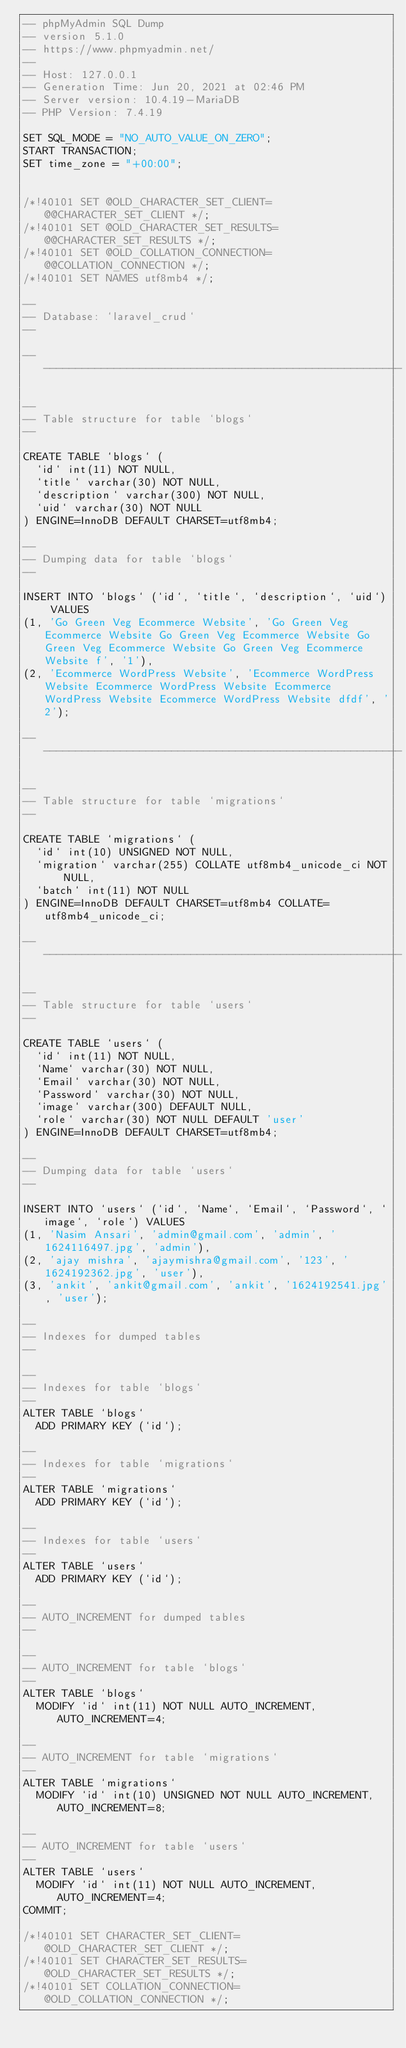<code> <loc_0><loc_0><loc_500><loc_500><_SQL_>-- phpMyAdmin SQL Dump
-- version 5.1.0
-- https://www.phpmyadmin.net/
--
-- Host: 127.0.0.1
-- Generation Time: Jun 20, 2021 at 02:46 PM
-- Server version: 10.4.19-MariaDB
-- PHP Version: 7.4.19

SET SQL_MODE = "NO_AUTO_VALUE_ON_ZERO";
START TRANSACTION;
SET time_zone = "+00:00";


/*!40101 SET @OLD_CHARACTER_SET_CLIENT=@@CHARACTER_SET_CLIENT */;
/*!40101 SET @OLD_CHARACTER_SET_RESULTS=@@CHARACTER_SET_RESULTS */;
/*!40101 SET @OLD_COLLATION_CONNECTION=@@COLLATION_CONNECTION */;
/*!40101 SET NAMES utf8mb4 */;

--
-- Database: `laravel_crud`
--

-- --------------------------------------------------------

--
-- Table structure for table `blogs`
--

CREATE TABLE `blogs` (
  `id` int(11) NOT NULL,
  `title` varchar(30) NOT NULL,
  `description` varchar(300) NOT NULL,
  `uid` varchar(30) NOT NULL
) ENGINE=InnoDB DEFAULT CHARSET=utf8mb4;

--
-- Dumping data for table `blogs`
--

INSERT INTO `blogs` (`id`, `title`, `description`, `uid`) VALUES
(1, 'Go Green Veg Ecommerce Website', 'Go Green Veg Ecommerce Website Go Green Veg Ecommerce Website Go Green Veg Ecommerce Website Go Green Veg Ecommerce Website f', '1'),
(2, 'Ecommerce WordPress Website', 'Ecommerce WordPress Website Ecommerce WordPress Website Ecommerce WordPress Website Ecommerce WordPress Website dfdf', '2');

-- --------------------------------------------------------

--
-- Table structure for table `migrations`
--

CREATE TABLE `migrations` (
  `id` int(10) UNSIGNED NOT NULL,
  `migration` varchar(255) COLLATE utf8mb4_unicode_ci NOT NULL,
  `batch` int(11) NOT NULL
) ENGINE=InnoDB DEFAULT CHARSET=utf8mb4 COLLATE=utf8mb4_unicode_ci;

-- --------------------------------------------------------

--
-- Table structure for table `users`
--

CREATE TABLE `users` (
  `id` int(11) NOT NULL,
  `Name` varchar(30) NOT NULL,
  `Email` varchar(30) NOT NULL,
  `Password` varchar(30) NOT NULL,
  `image` varchar(300) DEFAULT NULL,
  `role` varchar(30) NOT NULL DEFAULT 'user'
) ENGINE=InnoDB DEFAULT CHARSET=utf8mb4;

--
-- Dumping data for table `users`
--

INSERT INTO `users` (`id`, `Name`, `Email`, `Password`, `image`, `role`) VALUES
(1, 'Nasim Ansari', 'admin@gmail.com', 'admin', '1624116497.jpg', 'admin'),
(2, 'ajay mishra', 'ajaymishra@gmail.com', '123', '1624192362.jpg', 'user'),
(3, 'ankit', 'ankit@gmail.com', 'ankit', '1624192541.jpg', 'user');

--
-- Indexes for dumped tables
--

--
-- Indexes for table `blogs`
--
ALTER TABLE `blogs`
  ADD PRIMARY KEY (`id`);

--
-- Indexes for table `migrations`
--
ALTER TABLE `migrations`
  ADD PRIMARY KEY (`id`);

--
-- Indexes for table `users`
--
ALTER TABLE `users`
  ADD PRIMARY KEY (`id`);

--
-- AUTO_INCREMENT for dumped tables
--

--
-- AUTO_INCREMENT for table `blogs`
--
ALTER TABLE `blogs`
  MODIFY `id` int(11) NOT NULL AUTO_INCREMENT, AUTO_INCREMENT=4;

--
-- AUTO_INCREMENT for table `migrations`
--
ALTER TABLE `migrations`
  MODIFY `id` int(10) UNSIGNED NOT NULL AUTO_INCREMENT, AUTO_INCREMENT=8;

--
-- AUTO_INCREMENT for table `users`
--
ALTER TABLE `users`
  MODIFY `id` int(11) NOT NULL AUTO_INCREMENT, AUTO_INCREMENT=4;
COMMIT;

/*!40101 SET CHARACTER_SET_CLIENT=@OLD_CHARACTER_SET_CLIENT */;
/*!40101 SET CHARACTER_SET_RESULTS=@OLD_CHARACTER_SET_RESULTS */;
/*!40101 SET COLLATION_CONNECTION=@OLD_COLLATION_CONNECTION */;
</code> 